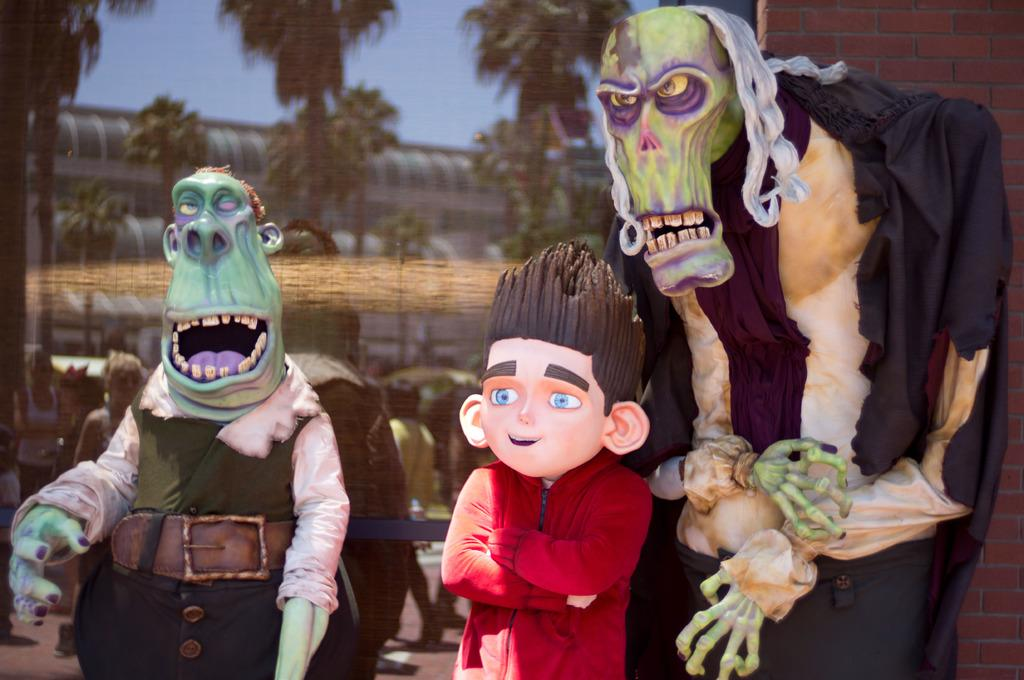What type of objects can be seen in the image? There are statues in the image. What is the nature of the image? The image is animated. What can be seen in the background of the image? There is a poster in the background of the image, which includes people and trees. What type of structure is present in the image? There is a brick wall in the image. What type of yoke is being used by the people in the image? There are no people or yokes present in the image; it features statues and an animated scene. What is the chance of winning a prize in the image? There is no indication of a prize or any game of chance in the image. 